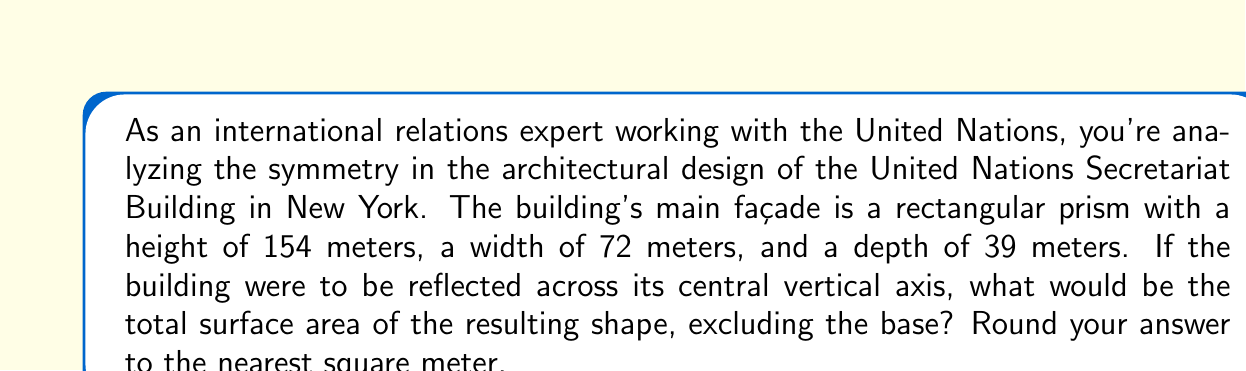Can you answer this question? To solve this problem, we need to follow these steps:

1) First, let's identify the surfaces we need to calculate:
   - Two front/back faces (identical)
   - Two side faces (identical)
   - Two top faces (identical, due to reflection)

2) Calculate the area of one front/back face:
   $$ A_{front} = 154 \text{ m} \times 72 \text{ m} = 11,088 \text{ m}^2 $$

3) Calculate the area of one side face:
   $$ A_{side} = 154 \text{ m} \times 39 \text{ m} = 6,006 \text{ m}^2 $$

4) Calculate the area of one top face:
   $$ A_{top} = 72 \text{ m} \times 39 \text{ m} = 2,808 \text{ m}^2 $$

5) Now, due to the reflection, we need to double each of these areas:
   $$ A_{total} = 2(A_{front} + A_{side} + A_{top}) $$
   $$ A_{total} = 2(11,088 + 6,006 + 2,808) \text{ m}^2 $$
   $$ A_{total} = 2(19,902) \text{ m}^2 $$
   $$ A_{total} = 39,804 \text{ m}^2 $$

6) Rounding to the nearest square meter:
   $$ A_{total} \approx 39,804 \text{ m}^2 $$

This problem demonstrates how symmetry in architecture can be analyzed using geometric principles, connecting the fields of international relations and mathematics.
Answer: 39,804 m² 